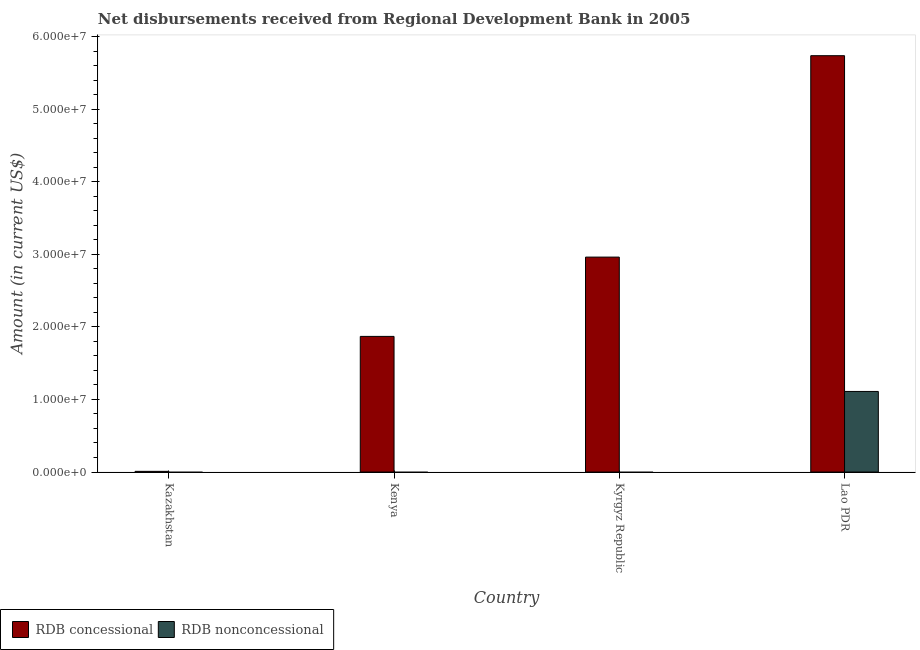Are the number of bars per tick equal to the number of legend labels?
Ensure brevity in your answer.  No. Are the number of bars on each tick of the X-axis equal?
Your response must be concise. No. How many bars are there on the 2nd tick from the left?
Ensure brevity in your answer.  1. How many bars are there on the 1st tick from the right?
Keep it short and to the point. 2. What is the label of the 1st group of bars from the left?
Your answer should be compact. Kazakhstan. In how many cases, is the number of bars for a given country not equal to the number of legend labels?
Make the answer very short. 3. Across all countries, what is the maximum net concessional disbursements from rdb?
Keep it short and to the point. 5.74e+07. Across all countries, what is the minimum net non concessional disbursements from rdb?
Make the answer very short. 0. In which country was the net non concessional disbursements from rdb maximum?
Make the answer very short. Lao PDR. What is the total net non concessional disbursements from rdb in the graph?
Provide a succinct answer. 1.11e+07. What is the difference between the net concessional disbursements from rdb in Kazakhstan and that in Kyrgyz Republic?
Ensure brevity in your answer.  -2.95e+07. What is the difference between the net non concessional disbursements from rdb in Kazakhstan and the net concessional disbursements from rdb in Kyrgyz Republic?
Provide a succinct answer. -2.96e+07. What is the average net non concessional disbursements from rdb per country?
Your answer should be very brief. 2.78e+06. What is the difference between the net concessional disbursements from rdb and net non concessional disbursements from rdb in Lao PDR?
Make the answer very short. 4.63e+07. In how many countries, is the net non concessional disbursements from rdb greater than 30000000 US$?
Make the answer very short. 0. What is the ratio of the net concessional disbursements from rdb in Kyrgyz Republic to that in Lao PDR?
Your answer should be very brief. 0.52. What is the difference between the highest and the second highest net concessional disbursements from rdb?
Provide a succinct answer. 2.77e+07. What is the difference between the highest and the lowest net concessional disbursements from rdb?
Ensure brevity in your answer.  5.73e+07. Is the sum of the net concessional disbursements from rdb in Kenya and Lao PDR greater than the maximum net non concessional disbursements from rdb across all countries?
Provide a short and direct response. Yes. Are all the bars in the graph horizontal?
Give a very brief answer. No. What is the difference between two consecutive major ticks on the Y-axis?
Make the answer very short. 1.00e+07. Are the values on the major ticks of Y-axis written in scientific E-notation?
Ensure brevity in your answer.  Yes. Does the graph contain any zero values?
Give a very brief answer. Yes. Where does the legend appear in the graph?
Offer a terse response. Bottom left. What is the title of the graph?
Make the answer very short. Net disbursements received from Regional Development Bank in 2005. What is the label or title of the Y-axis?
Your answer should be compact. Amount (in current US$). What is the Amount (in current US$) in RDB concessional in Kazakhstan?
Offer a terse response. 9.50e+04. What is the Amount (in current US$) of RDB concessional in Kenya?
Keep it short and to the point. 1.87e+07. What is the Amount (in current US$) of RDB nonconcessional in Kenya?
Your response must be concise. 0. What is the Amount (in current US$) in RDB concessional in Kyrgyz Republic?
Your answer should be very brief. 2.96e+07. What is the Amount (in current US$) in RDB concessional in Lao PDR?
Offer a very short reply. 5.74e+07. What is the Amount (in current US$) in RDB nonconcessional in Lao PDR?
Your answer should be very brief. 1.11e+07. Across all countries, what is the maximum Amount (in current US$) in RDB concessional?
Provide a succinct answer. 5.74e+07. Across all countries, what is the maximum Amount (in current US$) in RDB nonconcessional?
Offer a very short reply. 1.11e+07. Across all countries, what is the minimum Amount (in current US$) of RDB concessional?
Your answer should be very brief. 9.50e+04. What is the total Amount (in current US$) in RDB concessional in the graph?
Your response must be concise. 1.06e+08. What is the total Amount (in current US$) in RDB nonconcessional in the graph?
Ensure brevity in your answer.  1.11e+07. What is the difference between the Amount (in current US$) of RDB concessional in Kazakhstan and that in Kenya?
Keep it short and to the point. -1.86e+07. What is the difference between the Amount (in current US$) in RDB concessional in Kazakhstan and that in Kyrgyz Republic?
Make the answer very short. -2.95e+07. What is the difference between the Amount (in current US$) of RDB concessional in Kazakhstan and that in Lao PDR?
Your answer should be very brief. -5.73e+07. What is the difference between the Amount (in current US$) in RDB concessional in Kenya and that in Kyrgyz Republic?
Ensure brevity in your answer.  -1.09e+07. What is the difference between the Amount (in current US$) in RDB concessional in Kenya and that in Lao PDR?
Your response must be concise. -3.87e+07. What is the difference between the Amount (in current US$) in RDB concessional in Kyrgyz Republic and that in Lao PDR?
Your answer should be very brief. -2.77e+07. What is the difference between the Amount (in current US$) in RDB concessional in Kazakhstan and the Amount (in current US$) in RDB nonconcessional in Lao PDR?
Your answer should be very brief. -1.10e+07. What is the difference between the Amount (in current US$) in RDB concessional in Kenya and the Amount (in current US$) in RDB nonconcessional in Lao PDR?
Make the answer very short. 7.58e+06. What is the difference between the Amount (in current US$) in RDB concessional in Kyrgyz Republic and the Amount (in current US$) in RDB nonconcessional in Lao PDR?
Offer a very short reply. 1.85e+07. What is the average Amount (in current US$) in RDB concessional per country?
Your answer should be very brief. 2.64e+07. What is the average Amount (in current US$) in RDB nonconcessional per country?
Offer a very short reply. 2.78e+06. What is the difference between the Amount (in current US$) in RDB concessional and Amount (in current US$) in RDB nonconcessional in Lao PDR?
Your response must be concise. 4.63e+07. What is the ratio of the Amount (in current US$) in RDB concessional in Kazakhstan to that in Kenya?
Keep it short and to the point. 0.01. What is the ratio of the Amount (in current US$) in RDB concessional in Kazakhstan to that in Kyrgyz Republic?
Offer a very short reply. 0. What is the ratio of the Amount (in current US$) in RDB concessional in Kazakhstan to that in Lao PDR?
Ensure brevity in your answer.  0. What is the ratio of the Amount (in current US$) of RDB concessional in Kenya to that in Kyrgyz Republic?
Your answer should be compact. 0.63. What is the ratio of the Amount (in current US$) in RDB concessional in Kenya to that in Lao PDR?
Give a very brief answer. 0.33. What is the ratio of the Amount (in current US$) of RDB concessional in Kyrgyz Republic to that in Lao PDR?
Your answer should be very brief. 0.52. What is the difference between the highest and the second highest Amount (in current US$) of RDB concessional?
Keep it short and to the point. 2.77e+07. What is the difference between the highest and the lowest Amount (in current US$) in RDB concessional?
Give a very brief answer. 5.73e+07. What is the difference between the highest and the lowest Amount (in current US$) of RDB nonconcessional?
Ensure brevity in your answer.  1.11e+07. 